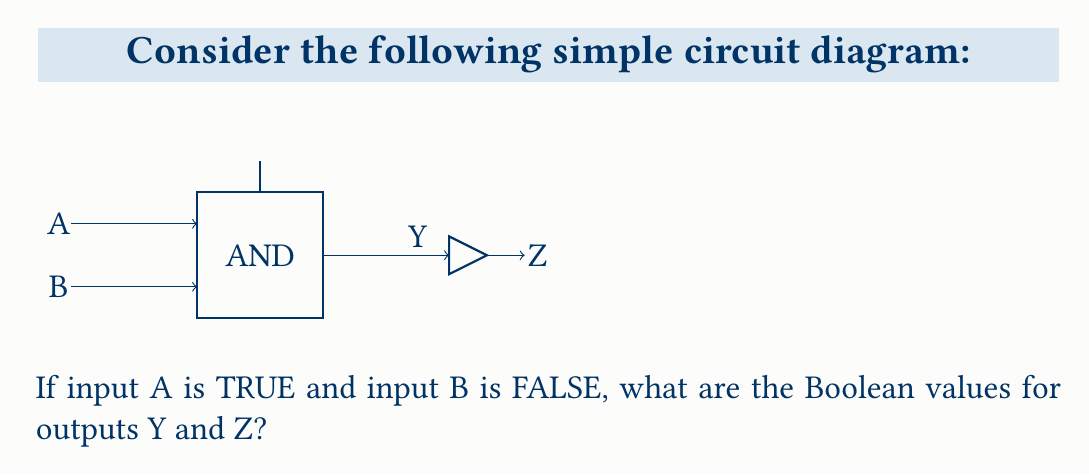What is the answer to this math problem? Let's analyze this circuit step-by-step:

1. The circuit consists of an AND gate followed by a NOT gate.

2. The AND gate:
   - It has two inputs: A and B
   - The output of the AND gate is Y
   - The Boolean expression for an AND gate is: $Y = A \cdot B$

3. Given information:
   - A is TRUE (we can represent this as A = 1)
   - B is FALSE (we can represent this as B = 0)

4. Calculate Y:
   $Y = A \cdot B = 1 \cdot 0 = 0$
   So, Y is FALSE

5. The NOT gate:
   - It has one input, which is the output Y from the AND gate
   - The output of the NOT gate is Z
   - The Boolean expression for a NOT gate is: $Z = \overline{Y}$

6. Calculate Z:
   Since Y is FALSE (0), Z will be the opposite:
   $Z = \overline{Y} = \overline{0} = 1$
   So, Z is TRUE

Therefore, Y is FALSE and Z is TRUE.
Answer: Y = FALSE, Z = TRUE 